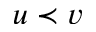Convert formula to latex. <formula><loc_0><loc_0><loc_500><loc_500>u \prec v</formula> 